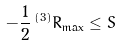Convert formula to latex. <formula><loc_0><loc_0><loc_500><loc_500>- \frac { 1 } { 2 } \, ^ { \left ( 3 \right ) } R _ { \max } \leq S</formula> 